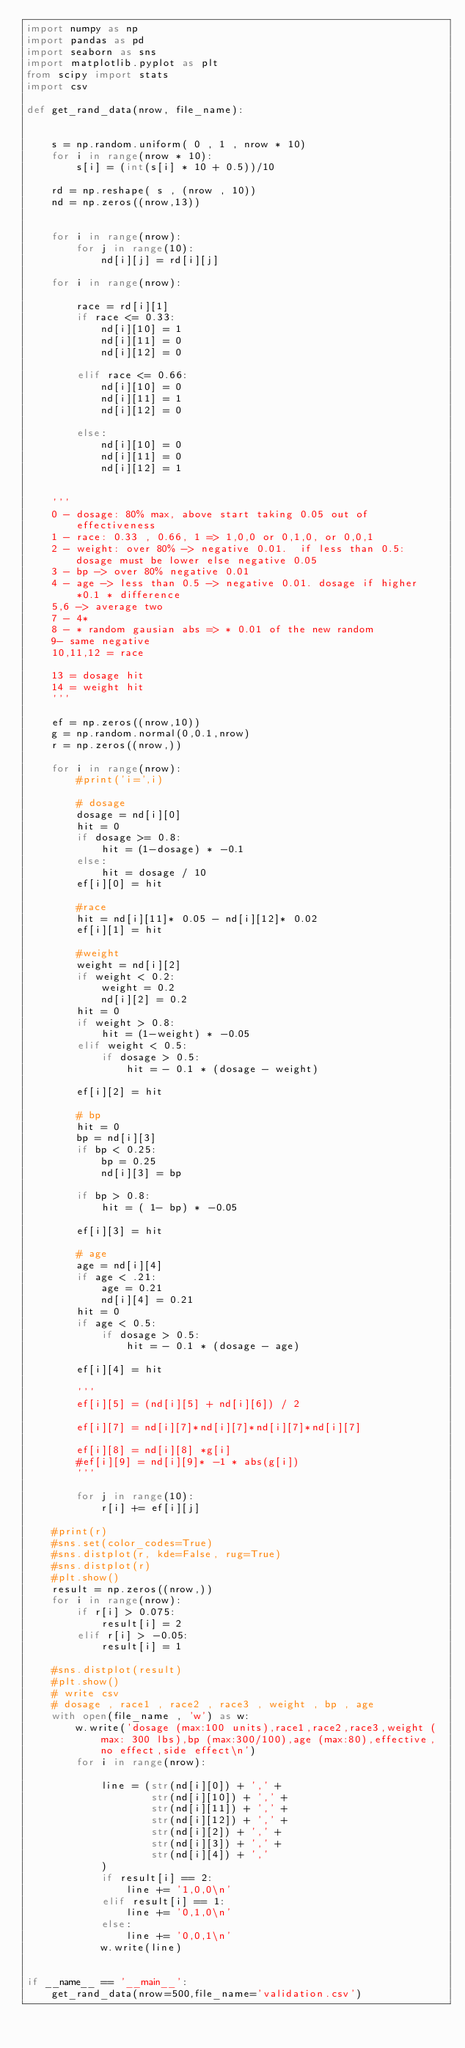<code> <loc_0><loc_0><loc_500><loc_500><_Python_>import numpy as np
import pandas as pd
import seaborn as sns
import matplotlib.pyplot as plt
from scipy import stats
import csv

def get_rand_data(nrow, file_name):


    s = np.random.uniform( 0 , 1 , nrow * 10)
    for i in range(nrow * 10):
        s[i] = (int(s[i] * 10 + 0.5))/10

    rd = np.reshape( s , (nrow , 10))
    nd = np.zeros((nrow,13))


    for i in range(nrow):
        for j in range(10):
            nd[i][j] = rd[i][j]

    for i in range(nrow):
        
        race = rd[i][1]
        if race <= 0.33:
            nd[i][10] = 1
            nd[i][11] = 0
            nd[i][12] = 0

        elif race <= 0.66:
            nd[i][10] = 0
            nd[i][11] = 1
            nd[i][12] = 0

        else:
            nd[i][10] = 0
            nd[i][11] = 0
            nd[i][12] = 1


    '''
    0 - dosage: 80% max, above start taking 0.05 out of effectiveness
    1 - race: 0.33 , 0.66, 1 => 1,0,0 or 0,1,0, or 0,0,1
    2 - weight: over 80% -> negative 0.01.  if less than 0.5: dosage must be lower else negative 0.05
    3 - bp -> over 80% negative 0.01
    4 - age -> less than 0.5 -> negative 0.01. dosage if higher *0.1 * difference
    5,6 -> average two
    7 - 4*
    8 - * random gausian abs => * 0.01 of the new random
    9- same negative
    10,11,12 = race

    13 = dosage hit
    14 = weight hit
    '''

    ef = np.zeros((nrow,10))
    g = np.random.normal(0,0.1,nrow)
    r = np.zeros((nrow,))

    for i in range(nrow):
        #print('i=',i)

        # dosage
        dosage = nd[i][0]
        hit = 0
        if dosage >= 0.8:
            hit = (1-dosage) * -0.1
        else:
            hit = dosage / 10
        ef[i][0] = hit

        #race
        hit = nd[i][11]* 0.05 - nd[i][12]* 0.02
        ef[i][1] = hit

        #weight
        weight = nd[i][2]
        if weight < 0.2:
            weight = 0.2
            nd[i][2] = 0.2
        hit = 0
        if weight > 0.8:
            hit = (1-weight) * -0.05
        elif weight < 0.5:
            if dosage > 0.5:
                hit = - 0.1 * (dosage - weight)

        ef[i][2] = hit

        # bp
        hit = 0
        bp = nd[i][3]
        if bp < 0.25:
            bp = 0.25
            nd[i][3] = bp

        if bp > 0.8:
            hit = ( 1- bp) * -0.05

        ef[i][3] = hit

        # age
        age = nd[i][4]
        if age < .21:
            age = 0.21
            nd[i][4] = 0.21
        hit = 0
        if age < 0.5:
            if dosage > 0.5:
                hit = - 0.1 * (dosage - age)

        ef[i][4] = hit

        '''
        ef[i][5] = (nd[i][5] + nd[i][6]) / 2

        ef[i][7] = nd[i][7]*nd[i][7]*nd[i][7]*nd[i][7]

        ef[i][8] = nd[i][8] *g[i]
        #ef[i][9] = nd[i][9]* -1 * abs(g[i])
        '''

        for j in range(10):
            r[i] += ef[i][j]

    #print(r)
    #sns.set(color_codes=True)
    #sns.distplot(r, kde=False, rug=True)
    #sns.distplot(r)
    #plt.show()
    result = np.zeros((nrow,))
    for i in range(nrow):
        if r[i] > 0.075:
            result[i] = 2
        elif r[i] > -0.05:
            result[i] = 1

    #sns.distplot(result)
    #plt.show()
    # write csv
    # dosage , race1 , race2 , race3 , weight , bp , age
    with open(file_name , 'w') as w:
        w.write('dosage (max:100 units),race1,race2,race3,weight (max: 300 lbs),bp (max:300/100),age (max:80),effective,no effect,side effect\n')
        for i in range(nrow):
            
            line = (str(nd[i][0]) + ',' +
                    str(nd[i][10]) + ',' +
                    str(nd[i][11]) + ',' +
                    str(nd[i][12]) + ',' +
                    str(nd[i][2]) + ',' +
                    str(nd[i][3]) + ',' +
                    str(nd[i][4]) + ',' 
            )
            if result[i] == 2:
                line += '1,0,0\n'
            elif result[i] == 1:
                line += '0,1,0\n'
            else:
                line += '0,0,1\n'
            w.write(line)


if __name__ == '__main__':
    get_rand_data(nrow=500,file_name='validation.csv')</code> 